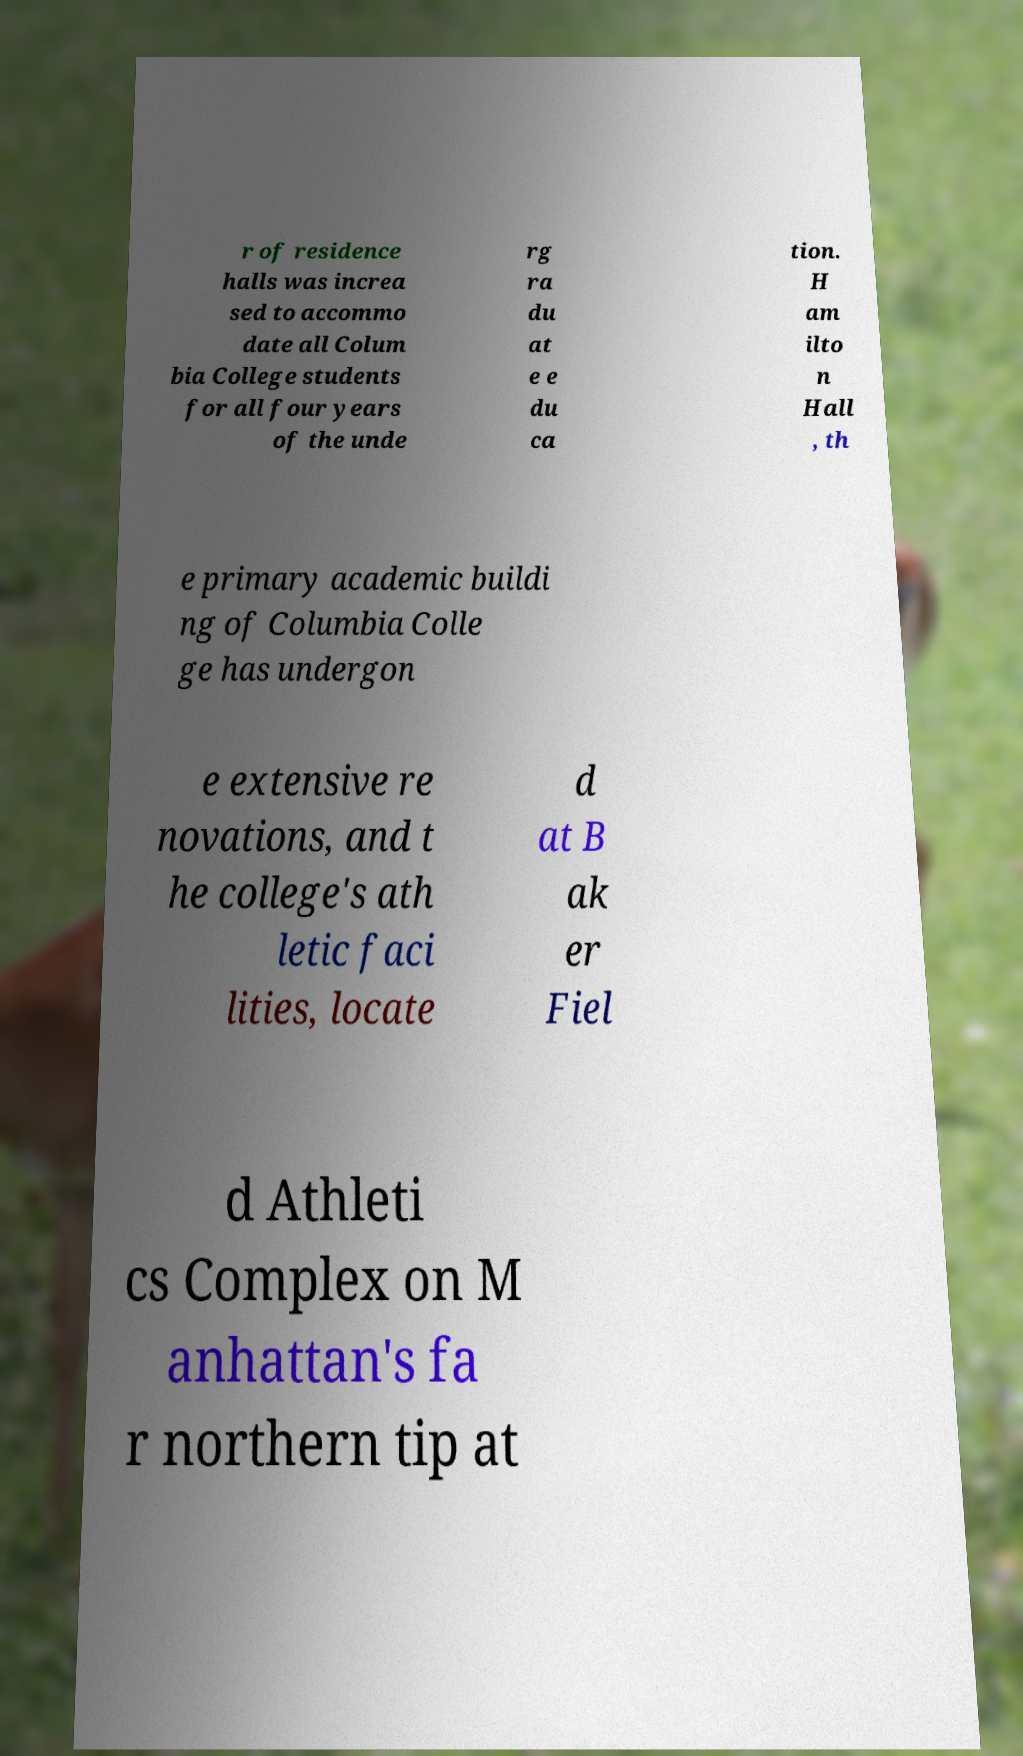There's text embedded in this image that I need extracted. Can you transcribe it verbatim? r of residence halls was increa sed to accommo date all Colum bia College students for all four years of the unde rg ra du at e e du ca tion. H am ilto n Hall , th e primary academic buildi ng of Columbia Colle ge has undergon e extensive re novations, and t he college's ath letic faci lities, locate d at B ak er Fiel d Athleti cs Complex on M anhattan's fa r northern tip at 